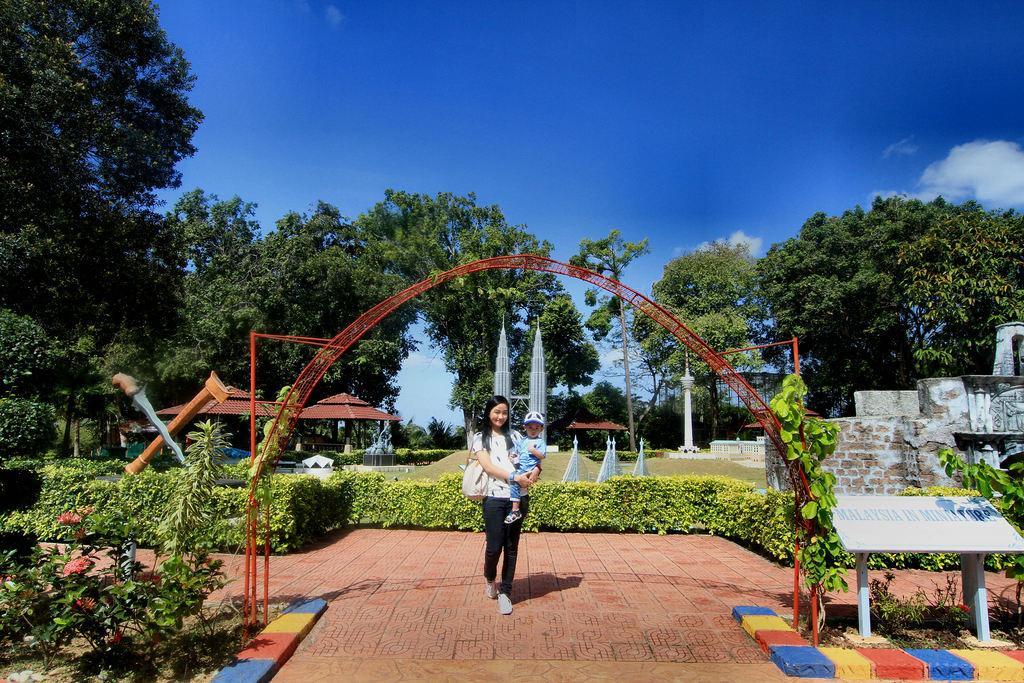Please provide a concise description of this image. There is a woman walking and holding a baby and carrying a bag. We can see arch, plants, flowers, board and wall. In the background we can see towers, orange color object, sheds, pole, trees and sky with clouds. 